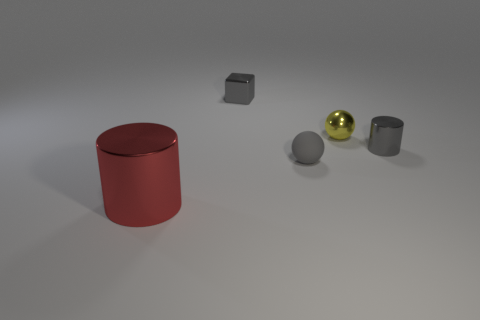Is there any other thing that has the same size as the red cylinder?
Your answer should be very brief. No. Are there fewer tiny metallic blocks behind the big cylinder than tiny gray shiny blocks?
Provide a succinct answer. No. What is the shape of the gray rubber object that is the same size as the yellow shiny sphere?
Provide a succinct answer. Sphere. How many other things are the same color as the small matte thing?
Your answer should be compact. 2. Is the metal block the same size as the yellow metallic thing?
Your response must be concise. Yes. How many objects are either small gray shiny things or small yellow metallic balls behind the red thing?
Provide a short and direct response. 3. Are there fewer tiny metal cylinders that are left of the yellow shiny ball than metal cylinders on the right side of the big red cylinder?
Provide a short and direct response. Yes. What number of other objects are the same material as the tiny gray ball?
Your answer should be very brief. 0. Does the tiny object that is behind the yellow ball have the same color as the tiny metal cylinder?
Your response must be concise. Yes. Are there any tiny gray shiny objects behind the small gray thing that is in front of the gray cylinder?
Your answer should be very brief. Yes. 